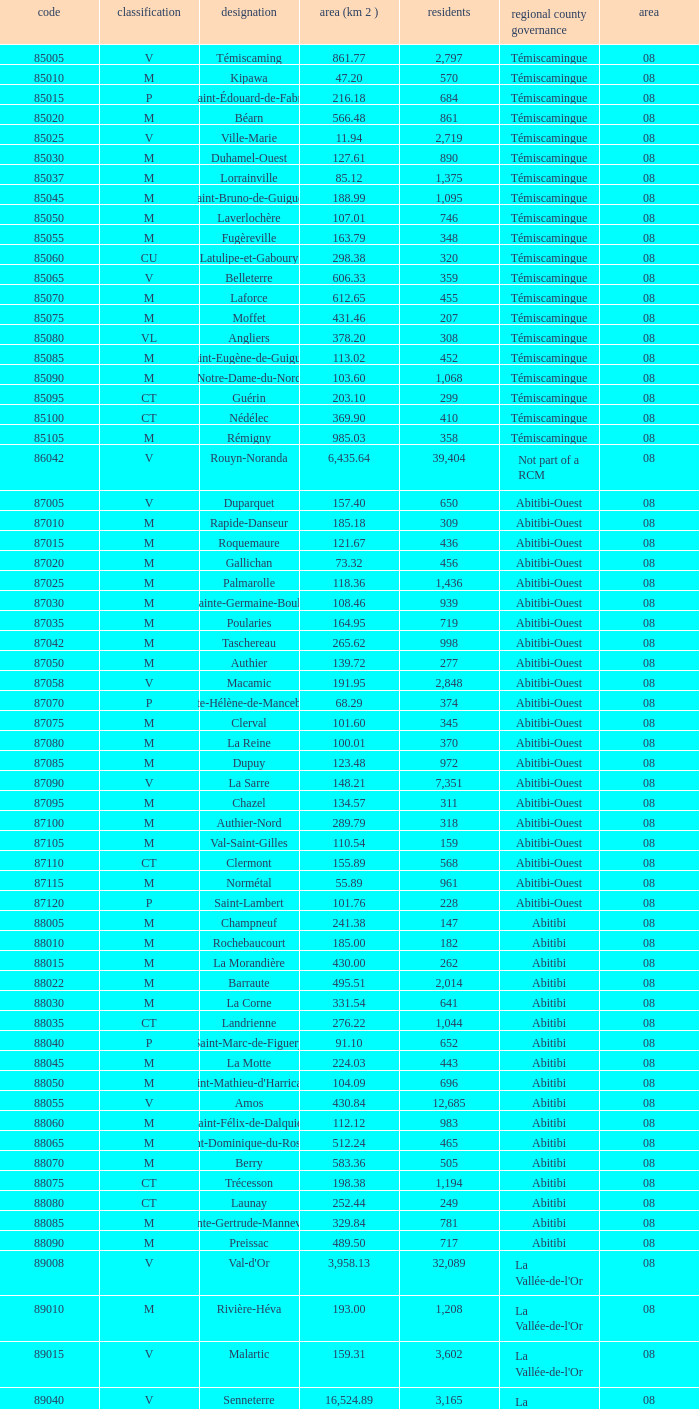What municipality has 719 people and is larger than 108.46 km2? Abitibi-Ouest. 